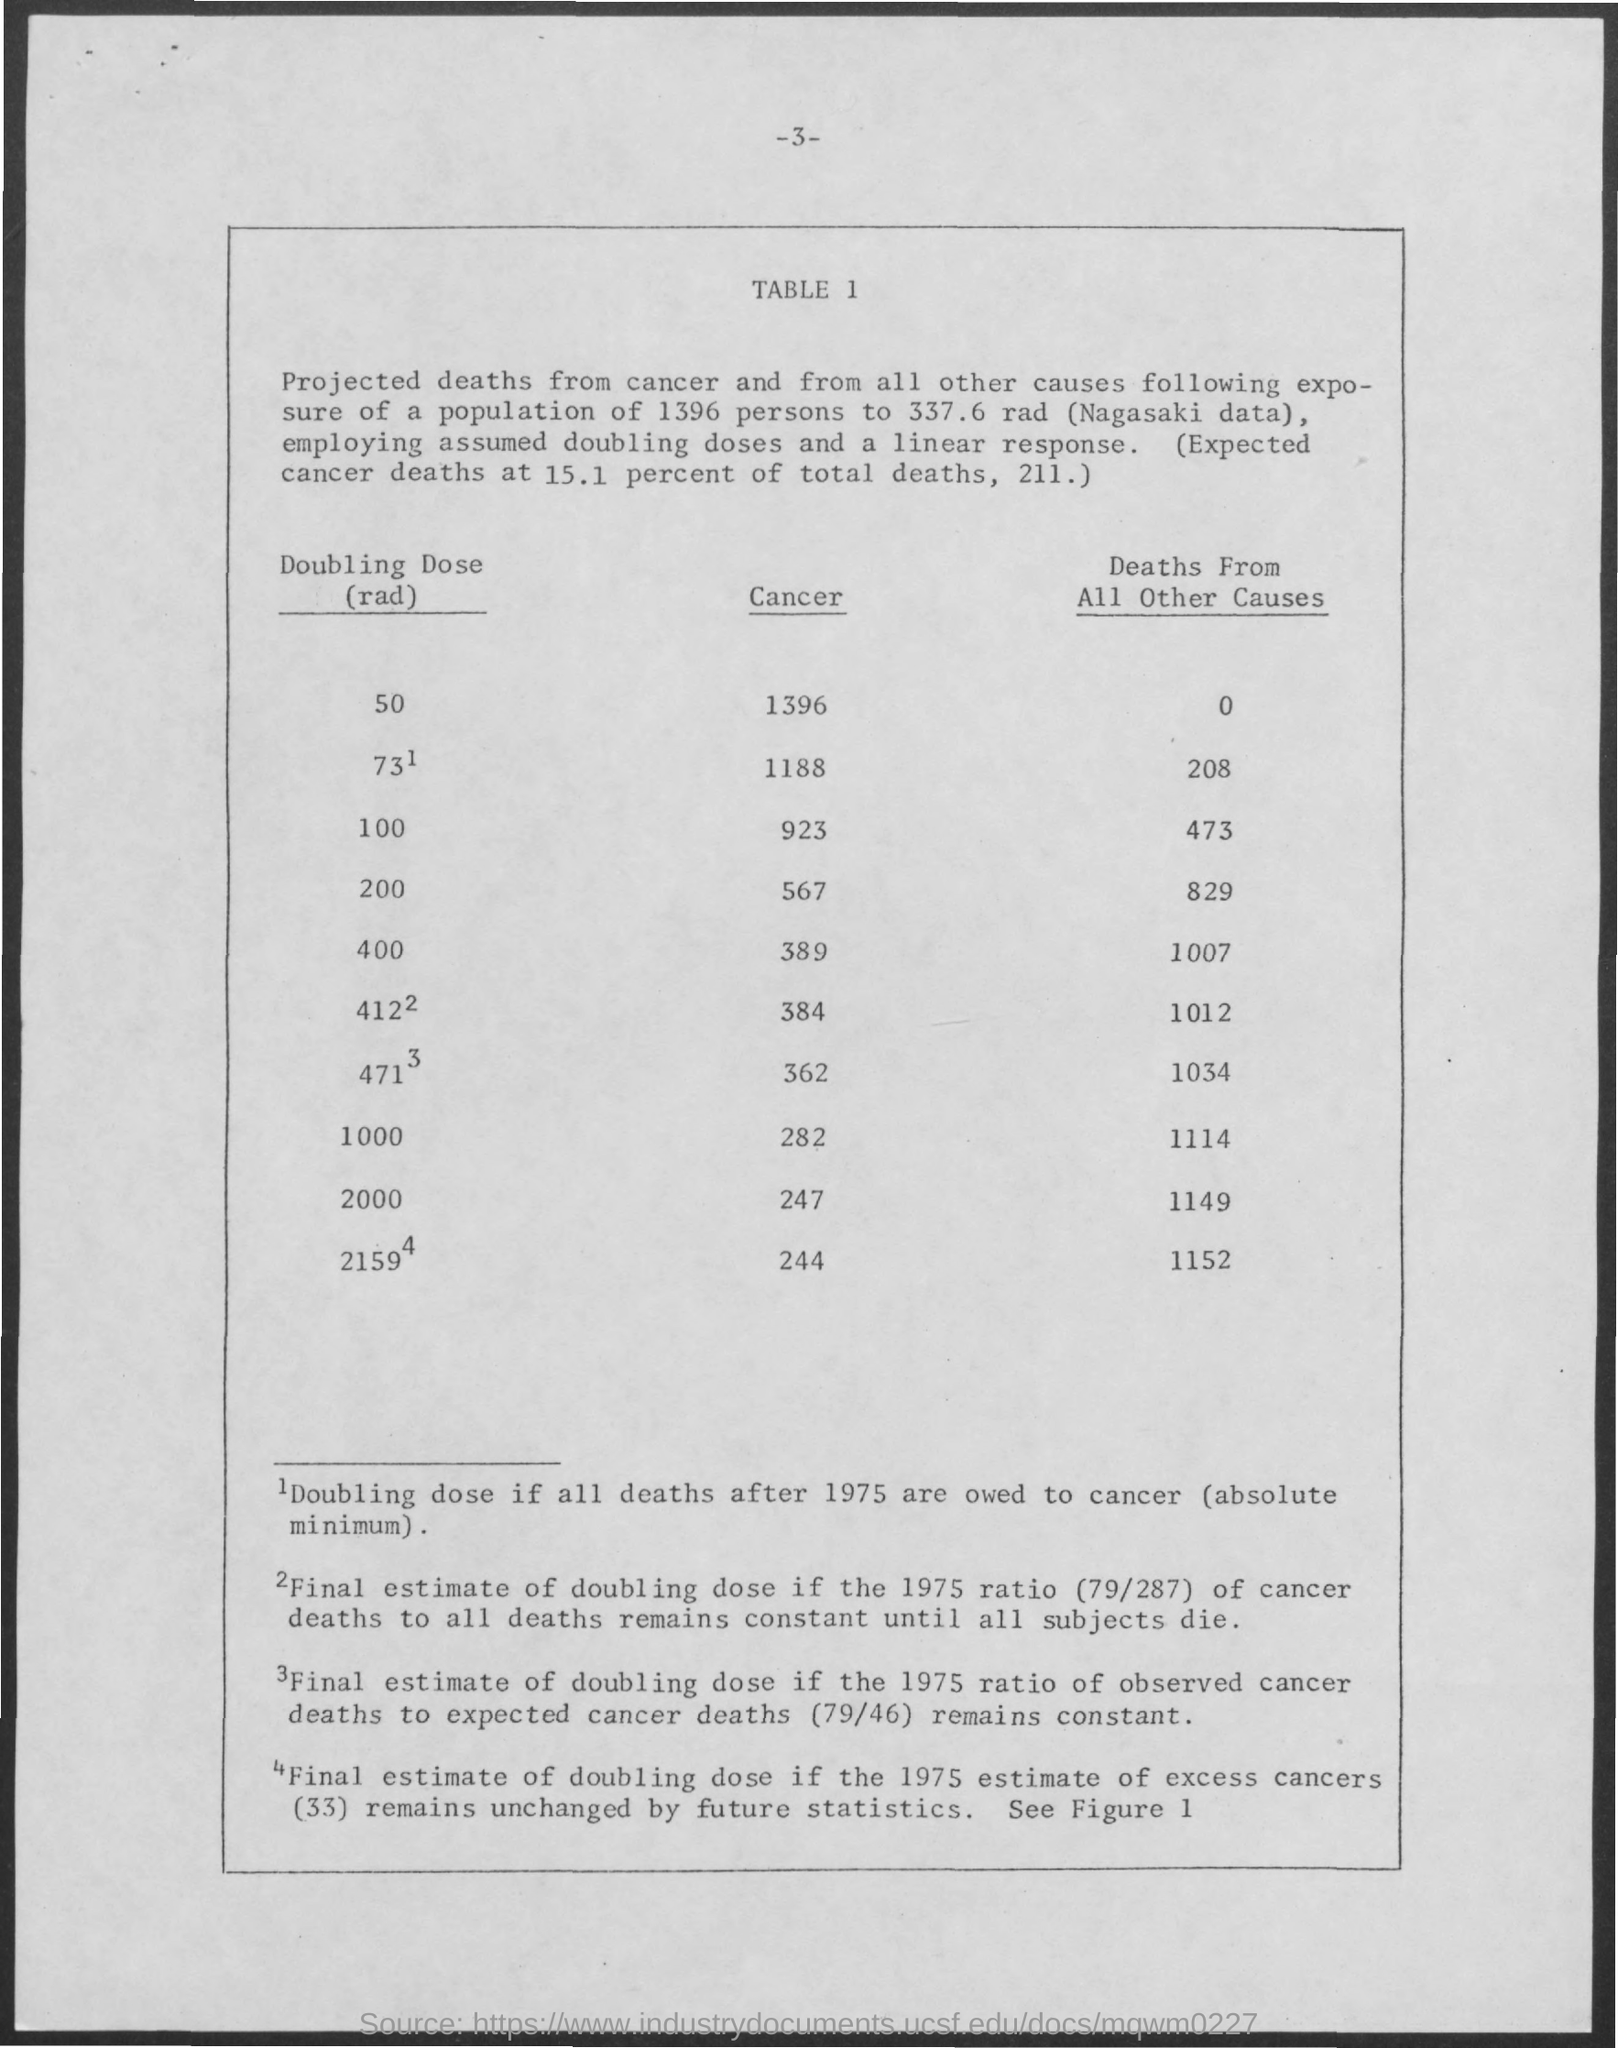What is the page number written on the top of the page?
Make the answer very short. 3. What is the heading of the first column of the TABLE?
Make the answer very short. Doubling Dose(rad). What is the heading of the second column of the TABLE?
Provide a succinct answer. Cancer. What is the heading of the third column of the TABLE?
Offer a very short reply. Deaths From All Other Causes. What is the number of Projected deaths from cancer for "Doubling Dose(rad)" value 2000?
Provide a short and direct response. 247. What is the number of Projected deaths from cancer for "Doubling Dose(rad)" value 100?
Make the answer very short. 923. What is the number of Projected deaths from cancer for "Doubling Dose(rad)" value 400?
Give a very brief answer. 389. What is the number of Projected "Deaths From All Other Causes" for "Doubling Dose(rad)" value 2000?
Your response must be concise. 1149. What is the number of Projected "Deaths From All Other Causes" for "Doubling Dose(rad)" value 100?
Ensure brevity in your answer.  473. What is the number of Projected "Deaths From All Other Causes" for "Doubling Dose(rad)" value 400?
Your answer should be compact. 1007. 